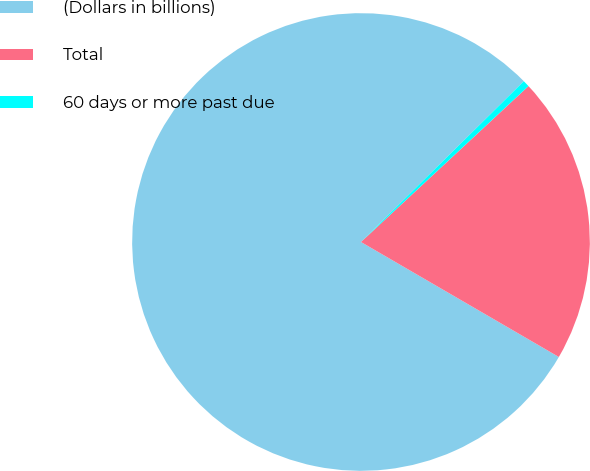Convert chart to OTSL. <chart><loc_0><loc_0><loc_500><loc_500><pie_chart><fcel>(Dollars in billions)<fcel>Total<fcel>60 days or more past due<nl><fcel>79.22%<fcel>20.31%<fcel>0.47%<nl></chart> 